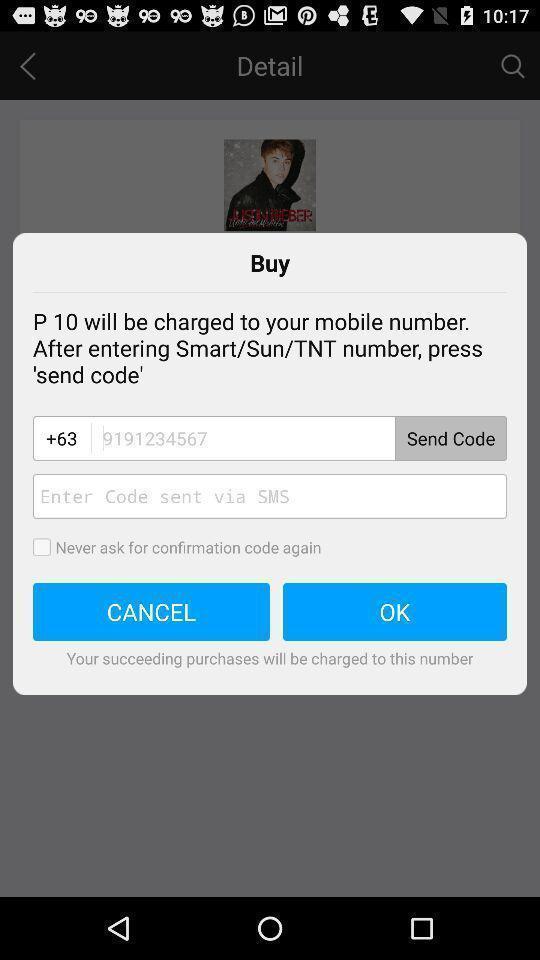What details can you identify in this image? Popup page of buy for entering sending code. 